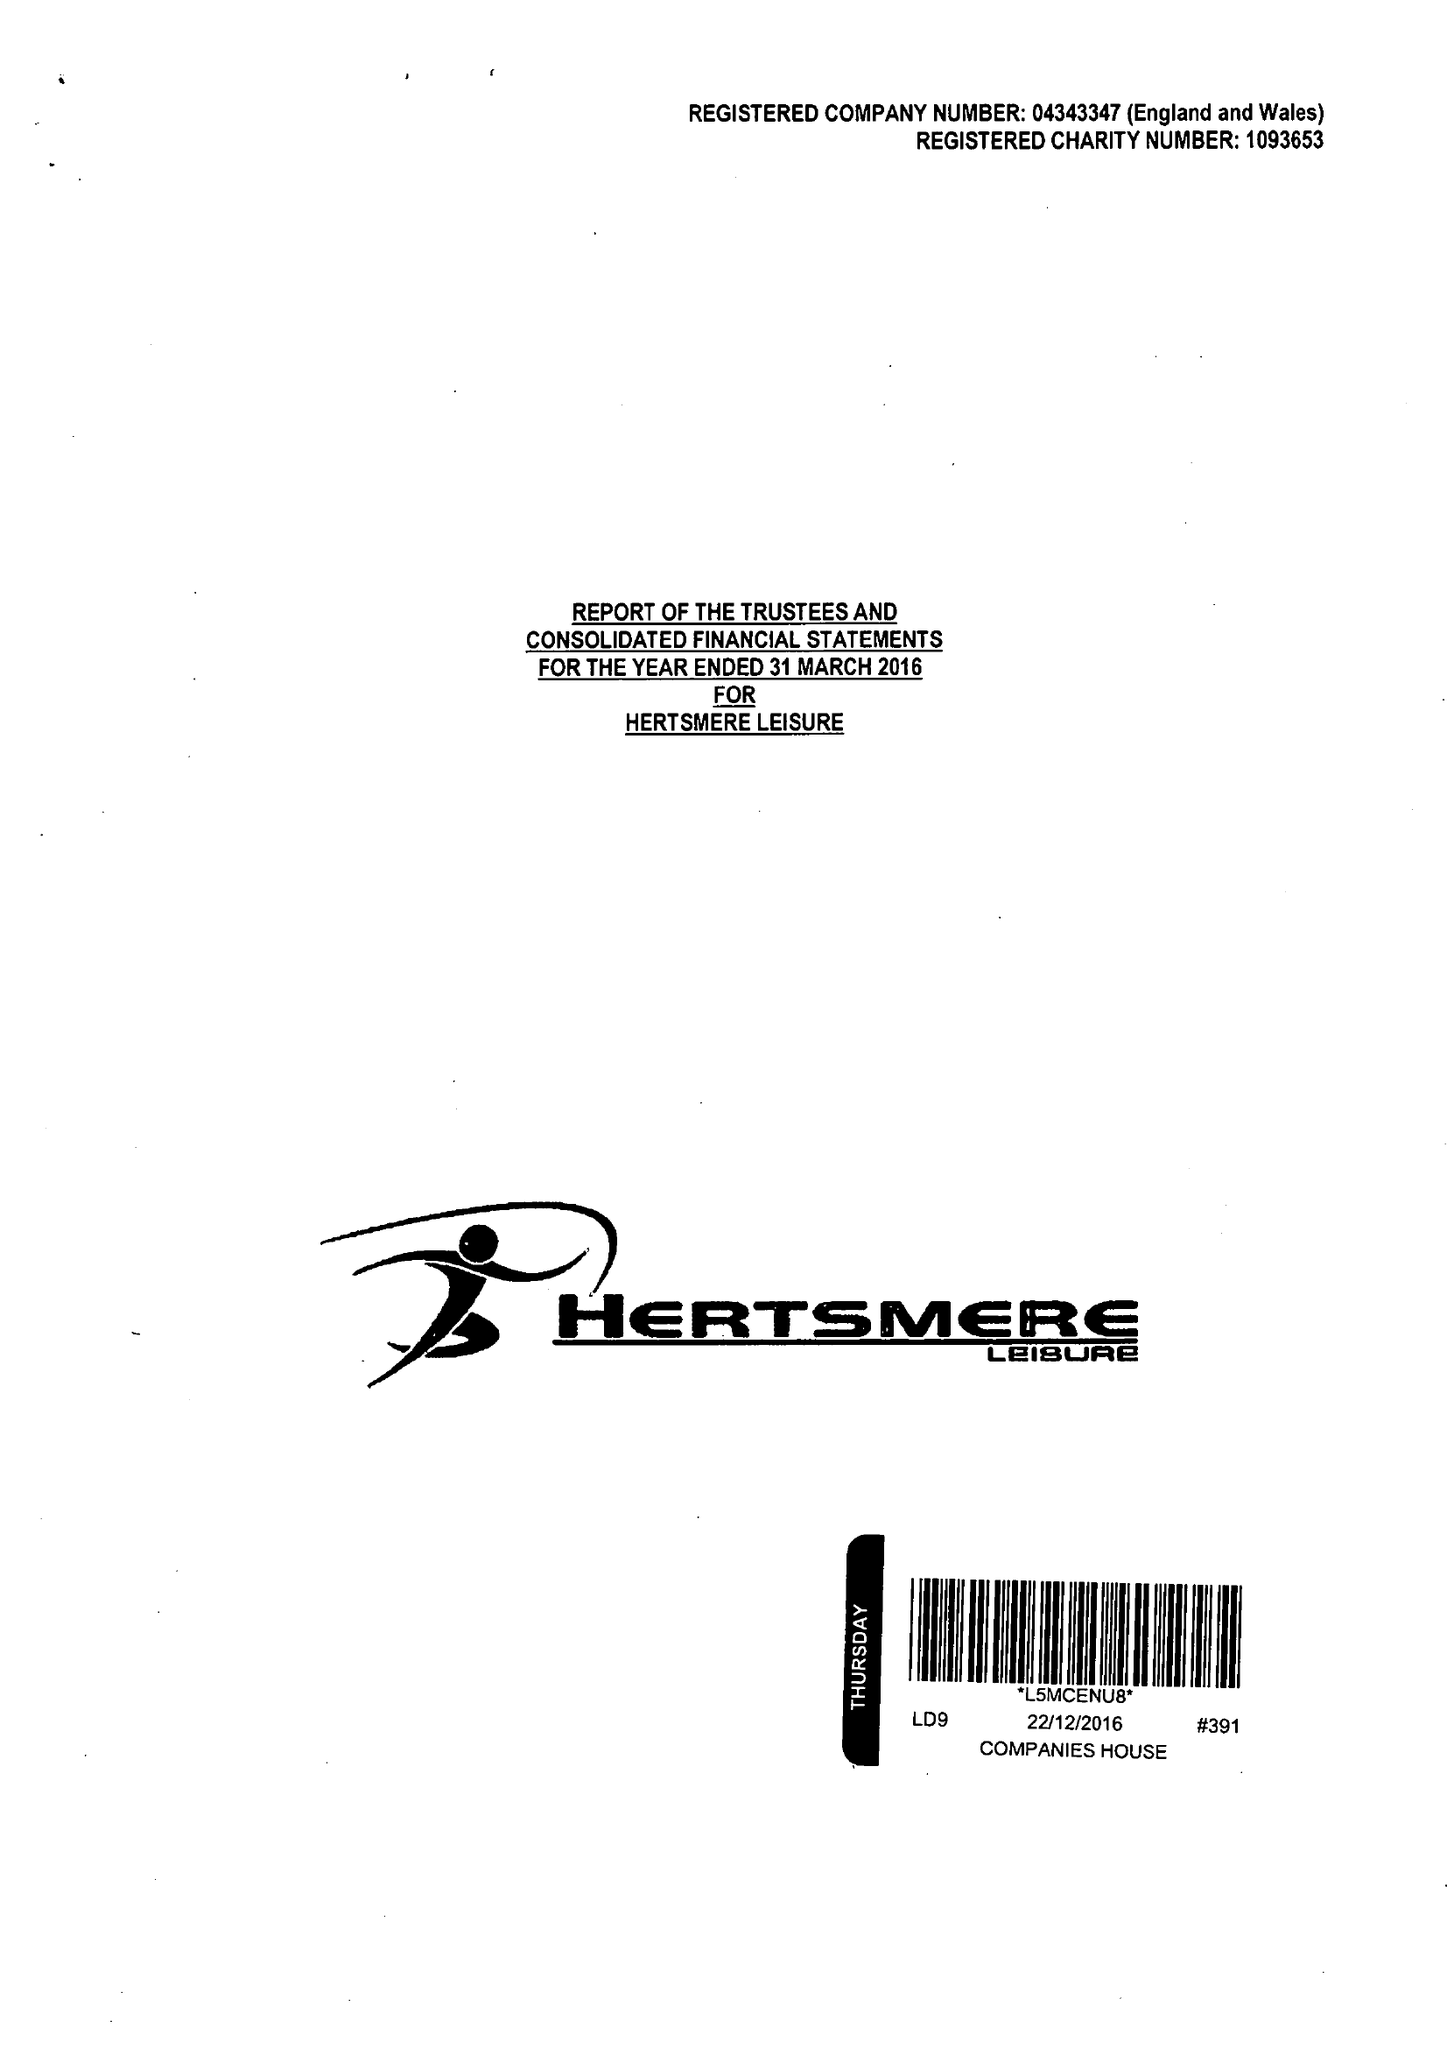What is the value for the charity_name?
Answer the question using a single word or phrase. Inspireall Leisure and Family Support Services 